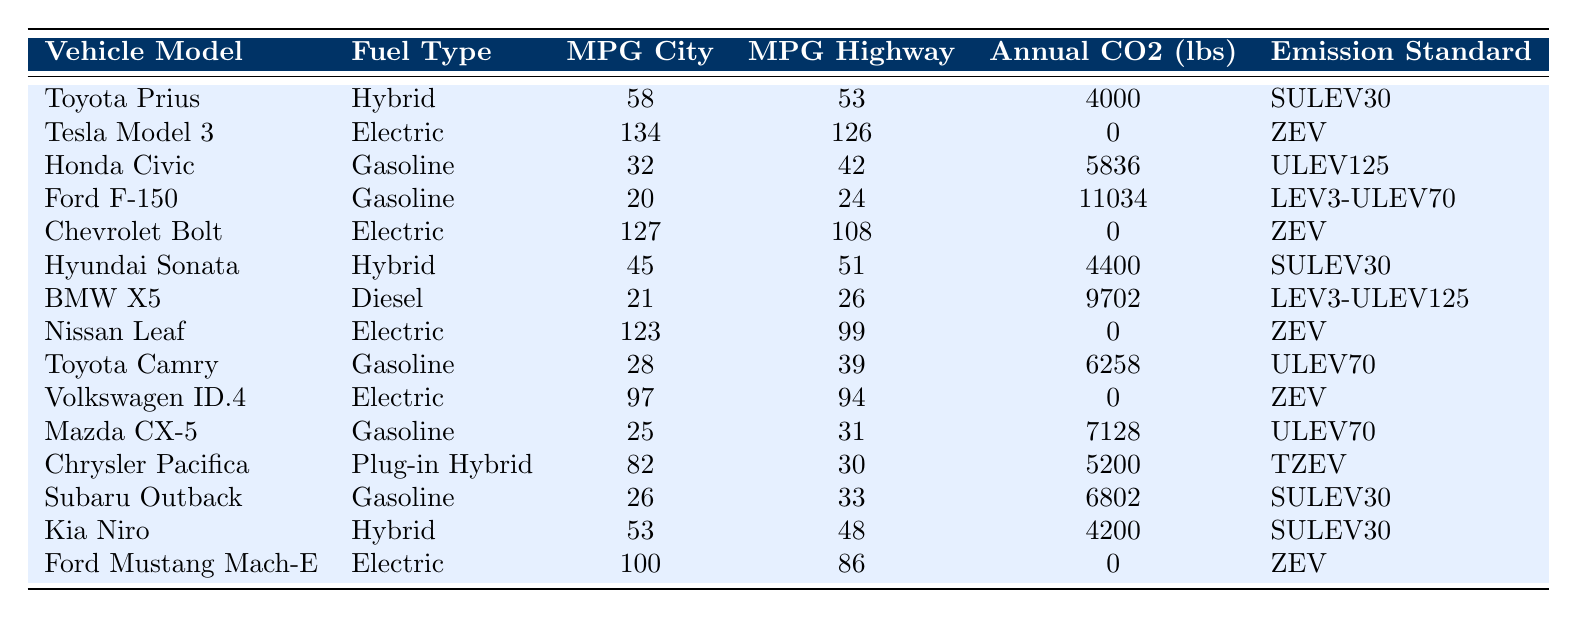What is the fuel type of the Toyota Prius? The table indicates that the fuel type for the Toyota Prius is listed in the second column. It shows "Hybrid" next to the vehicle model "Toyota Prius."
Answer: Hybrid Which vehicle model has the highest MPG in the city? By inspecting the "MPG City" column, we can see that the Tesla Model 3 has the highest MPG at 134.
Answer: Tesla Model 3 What is the annual CO2 emission of the Ford F-150? The annual CO2 emissions are provided in the fifth column of the table. For the Ford F-150, it is listed as 11,034 lbs.
Answer: 11034 lbs Is the Chevrolet Bolt an electric vehicle? Looking at the "Fuel Type" column, it indicates that the Chevrolet Bolt is an "Electric" vehicle. Thus, the statement is true.
Answer: Yes What is the average highway MPG for all gasoline vehicles listed? The gasoline vehicles listed are the Honda Civic, Ford F-150, Toyota Camry, Mazda CX-5, and Subaru Outback. Their highway MPG values are 42, 24, 39, 31, and 33 respectively. The sum is 169, and there are 5 vehicles, so the average is 169/5 = 33.8.
Answer: 33.8 Which vehicle emits the least annual CO2? The table lists the annual CO2 emissions for each vehicle. The Tesla Model 3, Chevrolet Bolt, Nissan Leaf, Volkswagen ID.4, and Ford Mustang Mach-E all emit 0 lbs. Hence, the vehicles listed exhibit the least emissions.
Answer: Tesla Model 3, Chevrolet Bolt, Nissan Leaf, Volkswagen ID.4, Ford Mustang Mach-E How many vehicles have a fuel type classified as hybrid? Looking at the fuel types, the hybrid vehicles are the Toyota Prius, Hyundai Sonata, and Kia Niro. There are 3 vehicles in total, which can be counted directly from the table.
Answer: 3 What is the difference in annual CO2 emissions between the Ford F-150 and the Honda Civic? The annual CO2 emissions for the Ford F-150 is 11,034 lbs and for the Honda Civic is 5,836 lbs. The difference is 11,034 - 5,836 = 5,198 lbs.
Answer: 5198 lbs Which vehicle has the highest MPG on the highway and what is its value? Checking the "MPG Highway" column, the vehicle with the highest MPG is the Tesla Model 3 at 126 MPG.
Answer: Tesla Model 3, 126 MPG Are there any vehicles with an emission standard of SULEV30? By examining the "Emission Standard" column, the vehicles that have SULEV30 as their emission standard are the Toyota Prius, Hyundai Sonata, and Kia Niro. Thus, the answer is yes.
Answer: Yes 